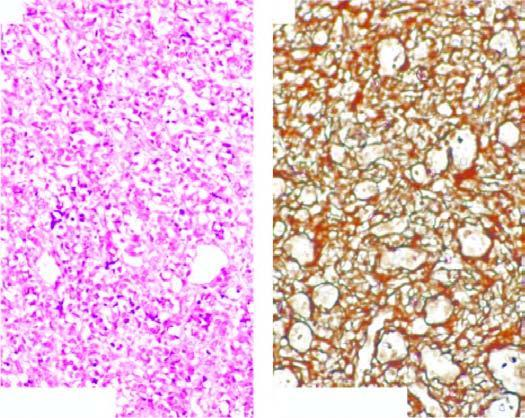does esions stain show condensation of reticulin around the vessel wall but not between the proliferating cells?
Answer the question using a single word or phrase. No 